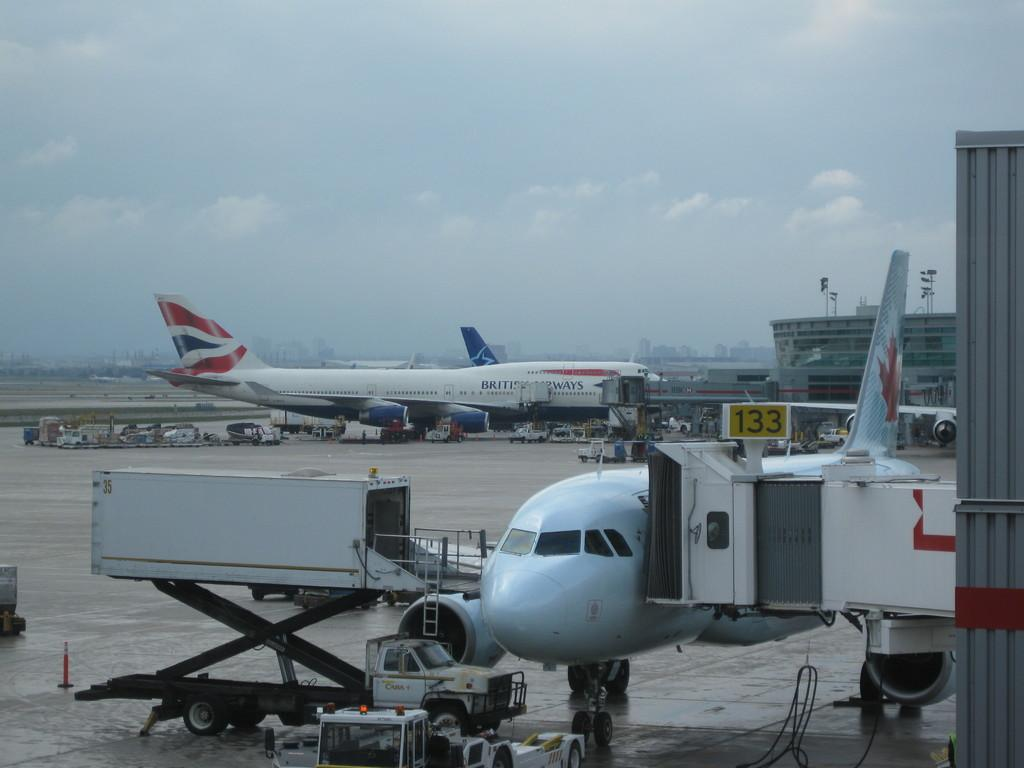<image>
Create a compact narrative representing the image presented. A red, white and blue British Airway plane is in the back. 